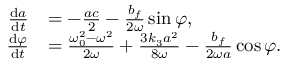Convert formula to latex. <formula><loc_0><loc_0><loc_500><loc_500>\begin{array} { r l } { \frac { d a } { d t } } & { = - \frac { a c } { 2 } - \frac { b _ { f } } { 2 \omega } \sin \varphi , } \\ { \frac { d \varphi } { d t } } & { = \frac { \omega _ { 0 } ^ { 2 } - \omega ^ { 2 } } { 2 \omega } + \frac { 3 k _ { 3 } a ^ { 2 } } { 8 \omega } - \frac { b _ { f } } { 2 \omega a } \cos \varphi . } \end{array}</formula> 